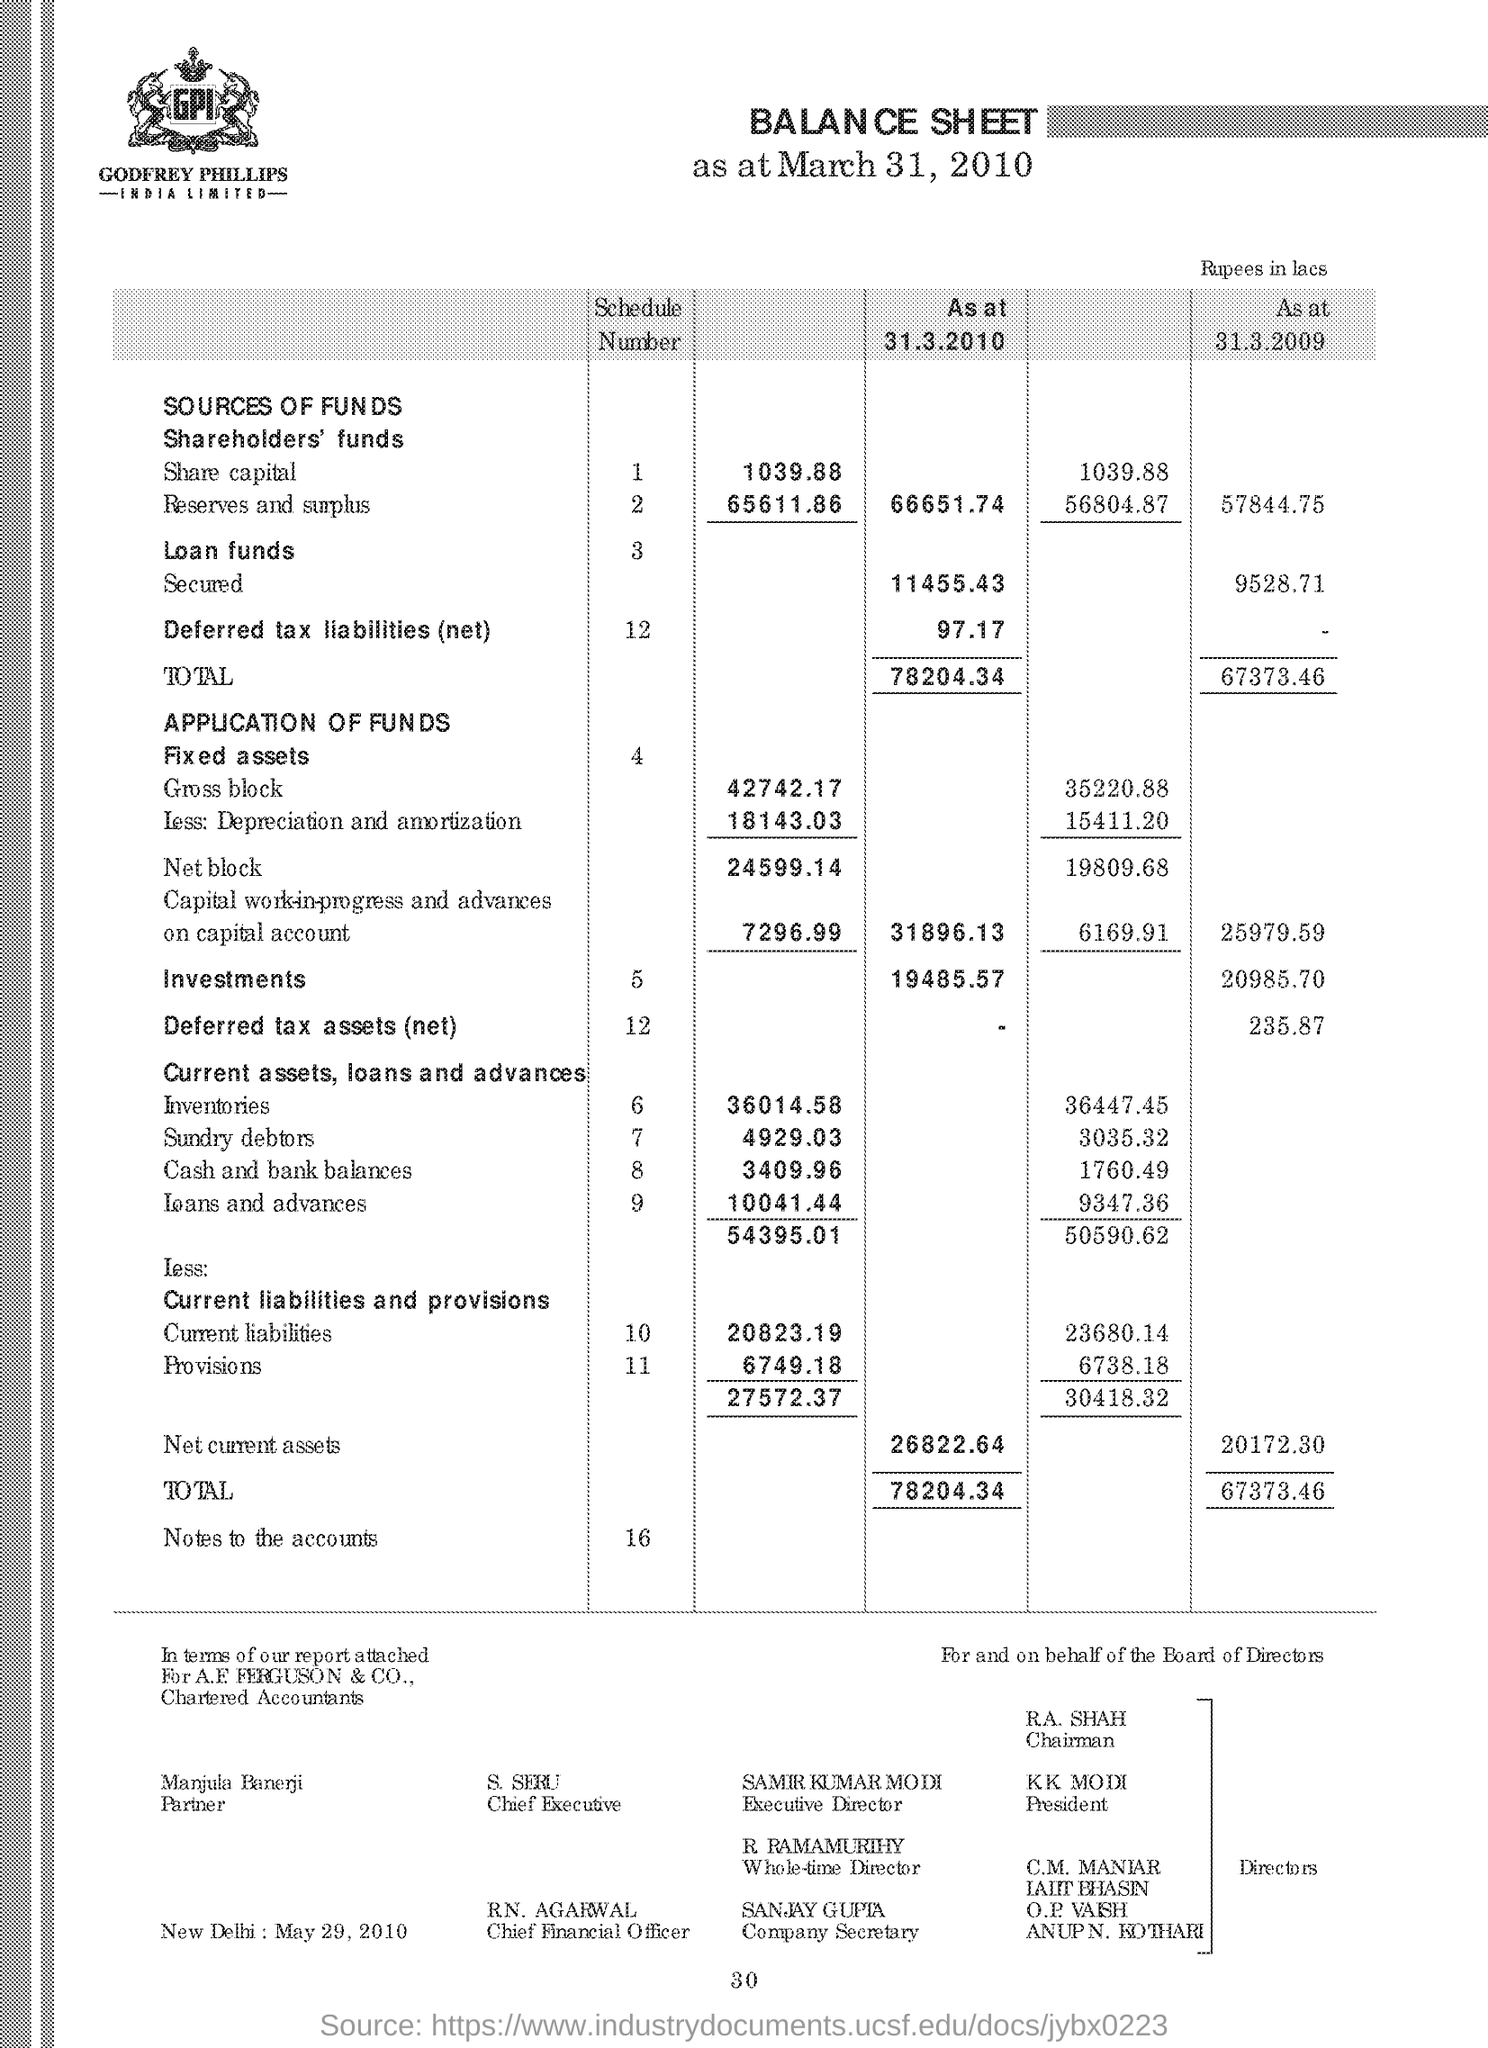Indicate a few pertinent items in this graphic. The person designated as the Company Secretary is Sanjay Gupta. As of March 31, 2010, the total was 78,204.34. The net current assets as at March 31, 2010 were 26,822.64. Samir Kumar Modi is the Executive Director. On March 31, 2009, the total was 67,373.46. 